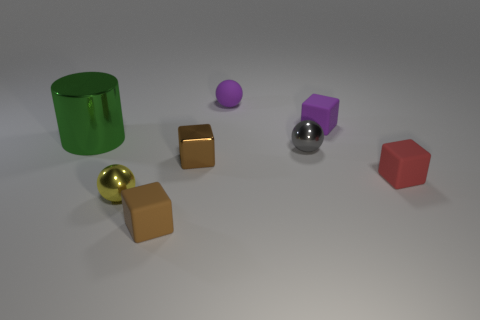What material is the other tiny brown thing that is the same shape as the small brown metallic thing?
Provide a short and direct response. Rubber. How many tiny rubber things are the same shape as the gray shiny thing?
Keep it short and to the point. 1. Are there any green cylinders that have the same size as the brown shiny cube?
Offer a terse response. No. How many metal things are large green cylinders or tiny brown cubes?
Give a very brief answer. 2. The thing that is the same color as the small shiny block is what shape?
Provide a succinct answer. Cube. What number of small brown rubber things are there?
Your answer should be very brief. 1. Are the brown thing in front of the red object and the brown thing behind the tiny yellow metallic object made of the same material?
Your answer should be very brief. No. What is the size of the yellow ball that is made of the same material as the big green cylinder?
Your answer should be very brief. Small. What shape is the green metallic thing to the left of the purple sphere?
Offer a terse response. Cylinder. Is the color of the small block that is behind the large green cylinder the same as the tiny rubber ball behind the tiny brown metal thing?
Offer a terse response. Yes. 